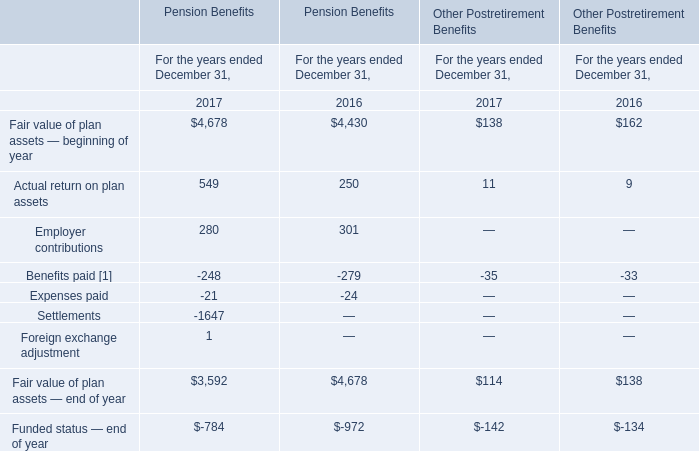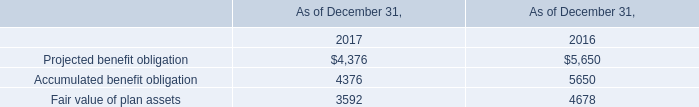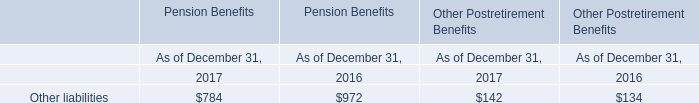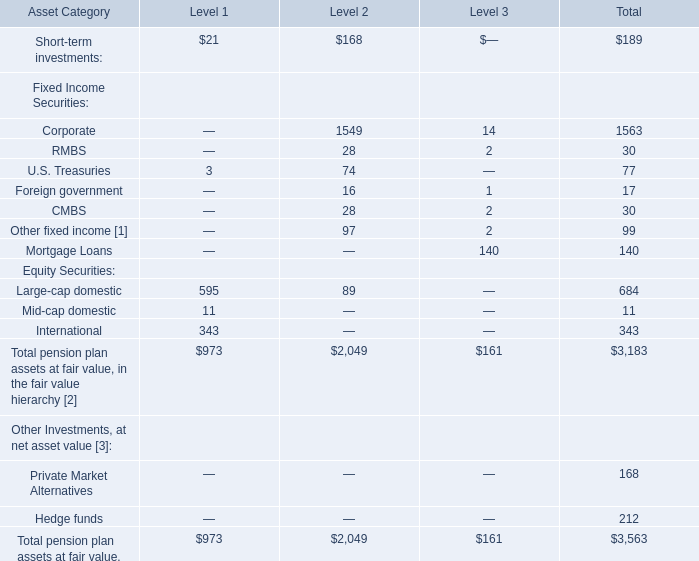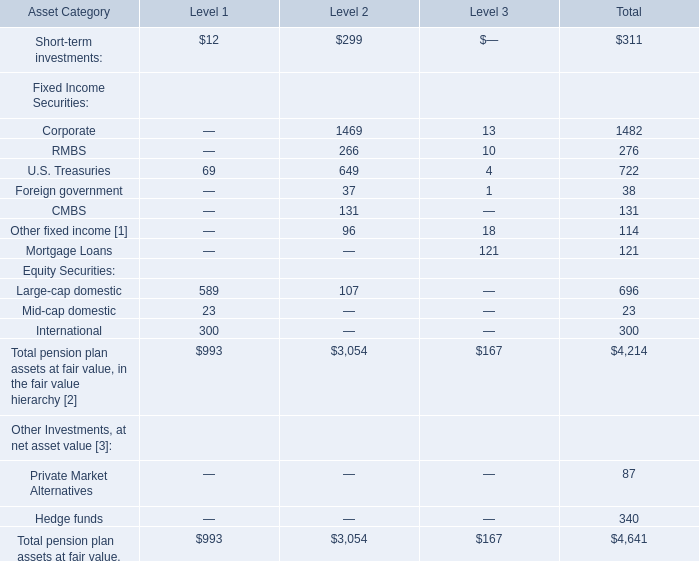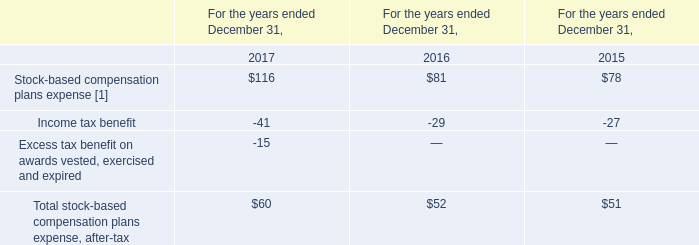What is the percentage of all Short-term investments that are positive to the total amount, in Total? 
Computations: (311 / 4214)
Answer: 0.0738. 